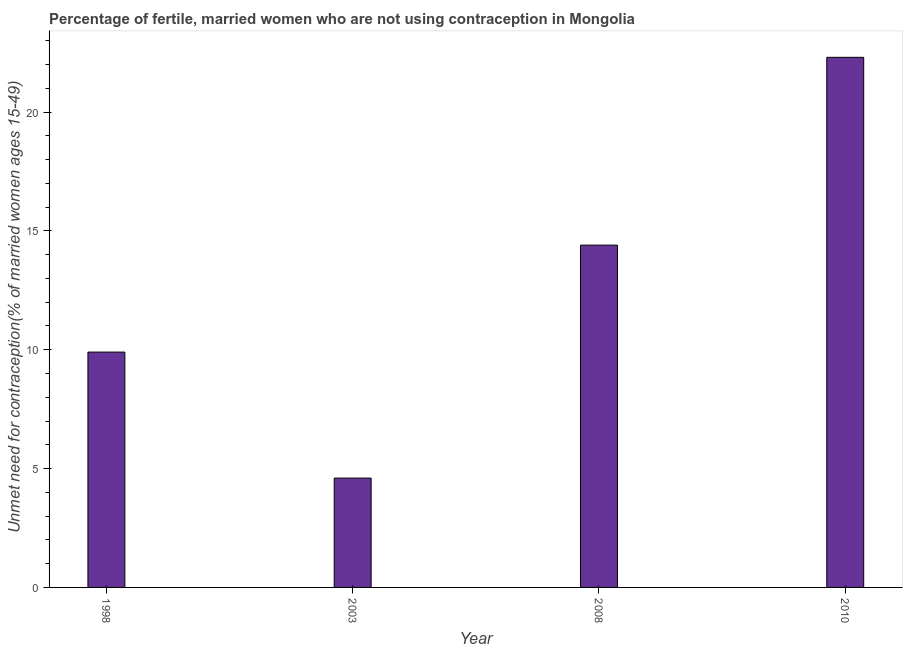Does the graph contain any zero values?
Keep it short and to the point. No. Does the graph contain grids?
Ensure brevity in your answer.  No. What is the title of the graph?
Provide a short and direct response. Percentage of fertile, married women who are not using contraception in Mongolia. What is the label or title of the X-axis?
Make the answer very short. Year. What is the label or title of the Y-axis?
Provide a short and direct response.  Unmet need for contraception(% of married women ages 15-49). Across all years, what is the maximum number of married women who are not using contraception?
Give a very brief answer. 22.3. Across all years, what is the minimum number of married women who are not using contraception?
Your response must be concise. 4.6. In which year was the number of married women who are not using contraception maximum?
Keep it short and to the point. 2010. What is the sum of the number of married women who are not using contraception?
Ensure brevity in your answer.  51.2. What is the average number of married women who are not using contraception per year?
Provide a short and direct response. 12.8. What is the median number of married women who are not using contraception?
Offer a terse response. 12.15. In how many years, is the number of married women who are not using contraception greater than 20 %?
Give a very brief answer. 1. Do a majority of the years between 1998 and 2010 (inclusive) have number of married women who are not using contraception greater than 2 %?
Your response must be concise. Yes. What is the ratio of the number of married women who are not using contraception in 1998 to that in 2010?
Your answer should be very brief. 0.44. Is the difference between the number of married women who are not using contraception in 1998 and 2010 greater than the difference between any two years?
Keep it short and to the point. No. What is the difference between the highest and the second highest number of married women who are not using contraception?
Your response must be concise. 7.9. Is the sum of the number of married women who are not using contraception in 2008 and 2010 greater than the maximum number of married women who are not using contraception across all years?
Offer a terse response. Yes. What is the difference between the highest and the lowest number of married women who are not using contraception?
Provide a succinct answer. 17.7. How many bars are there?
Ensure brevity in your answer.  4. What is the difference between two consecutive major ticks on the Y-axis?
Keep it short and to the point. 5. Are the values on the major ticks of Y-axis written in scientific E-notation?
Provide a succinct answer. No. What is the  Unmet need for contraception(% of married women ages 15-49) of 2003?
Your response must be concise. 4.6. What is the  Unmet need for contraception(% of married women ages 15-49) in 2010?
Keep it short and to the point. 22.3. What is the difference between the  Unmet need for contraception(% of married women ages 15-49) in 1998 and 2010?
Offer a terse response. -12.4. What is the difference between the  Unmet need for contraception(% of married women ages 15-49) in 2003 and 2008?
Offer a very short reply. -9.8. What is the difference between the  Unmet need for contraception(% of married women ages 15-49) in 2003 and 2010?
Make the answer very short. -17.7. What is the difference between the  Unmet need for contraception(% of married women ages 15-49) in 2008 and 2010?
Your answer should be very brief. -7.9. What is the ratio of the  Unmet need for contraception(% of married women ages 15-49) in 1998 to that in 2003?
Provide a succinct answer. 2.15. What is the ratio of the  Unmet need for contraception(% of married women ages 15-49) in 1998 to that in 2008?
Keep it short and to the point. 0.69. What is the ratio of the  Unmet need for contraception(% of married women ages 15-49) in 1998 to that in 2010?
Keep it short and to the point. 0.44. What is the ratio of the  Unmet need for contraception(% of married women ages 15-49) in 2003 to that in 2008?
Offer a very short reply. 0.32. What is the ratio of the  Unmet need for contraception(% of married women ages 15-49) in 2003 to that in 2010?
Provide a succinct answer. 0.21. What is the ratio of the  Unmet need for contraception(% of married women ages 15-49) in 2008 to that in 2010?
Your answer should be compact. 0.65. 